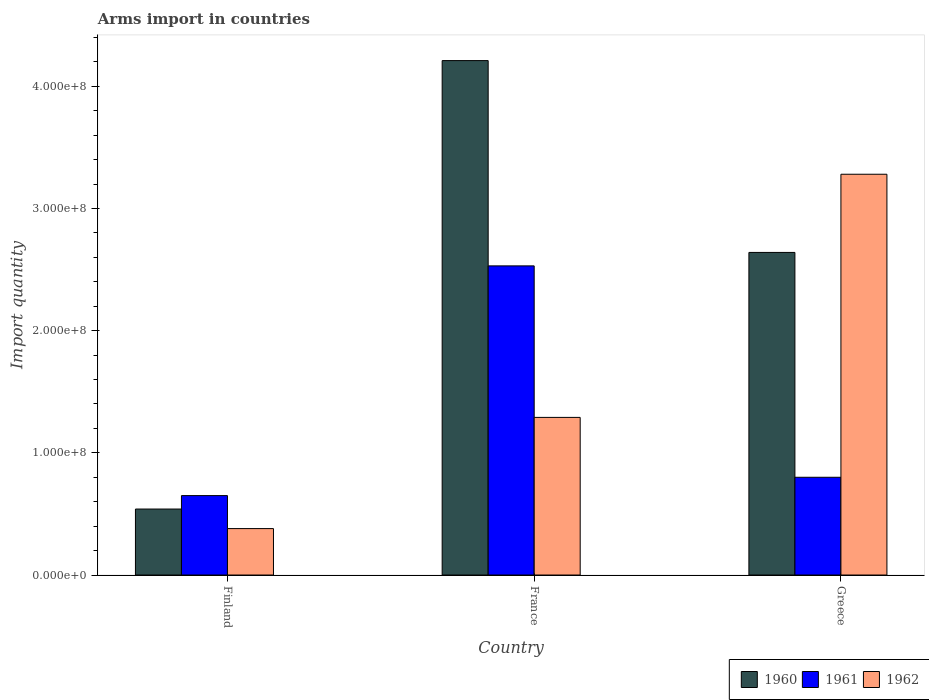How many different coloured bars are there?
Offer a terse response. 3. How many bars are there on the 1st tick from the right?
Provide a succinct answer. 3. What is the label of the 2nd group of bars from the left?
Offer a very short reply. France. What is the total arms import in 1960 in Greece?
Make the answer very short. 2.64e+08. Across all countries, what is the maximum total arms import in 1960?
Your response must be concise. 4.21e+08. Across all countries, what is the minimum total arms import in 1962?
Offer a terse response. 3.80e+07. What is the total total arms import in 1961 in the graph?
Give a very brief answer. 3.98e+08. What is the difference between the total arms import in 1962 in France and that in Greece?
Your answer should be compact. -1.99e+08. What is the difference between the total arms import in 1962 in Greece and the total arms import in 1961 in France?
Offer a very short reply. 7.50e+07. What is the average total arms import in 1961 per country?
Ensure brevity in your answer.  1.33e+08. What is the difference between the total arms import of/in 1960 and total arms import of/in 1962 in Finland?
Your answer should be compact. 1.60e+07. In how many countries, is the total arms import in 1962 greater than 400000000?
Give a very brief answer. 0. What is the ratio of the total arms import in 1960 in Finland to that in France?
Your answer should be very brief. 0.13. Is the difference between the total arms import in 1960 in France and Greece greater than the difference between the total arms import in 1962 in France and Greece?
Offer a very short reply. Yes. What is the difference between the highest and the second highest total arms import in 1960?
Give a very brief answer. 1.57e+08. What is the difference between the highest and the lowest total arms import in 1962?
Make the answer very short. 2.90e+08. In how many countries, is the total arms import in 1961 greater than the average total arms import in 1961 taken over all countries?
Offer a terse response. 1. Is the sum of the total arms import in 1962 in France and Greece greater than the maximum total arms import in 1960 across all countries?
Your answer should be compact. Yes. What does the 2nd bar from the left in France represents?
Your answer should be very brief. 1961. What does the 1st bar from the right in France represents?
Ensure brevity in your answer.  1962. Is it the case that in every country, the sum of the total arms import in 1960 and total arms import in 1962 is greater than the total arms import in 1961?
Offer a terse response. Yes. How many countries are there in the graph?
Offer a very short reply. 3. What is the difference between two consecutive major ticks on the Y-axis?
Offer a terse response. 1.00e+08. Are the values on the major ticks of Y-axis written in scientific E-notation?
Your answer should be very brief. Yes. Does the graph contain any zero values?
Provide a short and direct response. No. How many legend labels are there?
Your answer should be compact. 3. How are the legend labels stacked?
Your answer should be compact. Horizontal. What is the title of the graph?
Make the answer very short. Arms import in countries. What is the label or title of the X-axis?
Offer a very short reply. Country. What is the label or title of the Y-axis?
Offer a very short reply. Import quantity. What is the Import quantity in 1960 in Finland?
Your answer should be very brief. 5.40e+07. What is the Import quantity in 1961 in Finland?
Make the answer very short. 6.50e+07. What is the Import quantity of 1962 in Finland?
Give a very brief answer. 3.80e+07. What is the Import quantity of 1960 in France?
Give a very brief answer. 4.21e+08. What is the Import quantity in 1961 in France?
Provide a succinct answer. 2.53e+08. What is the Import quantity of 1962 in France?
Make the answer very short. 1.29e+08. What is the Import quantity of 1960 in Greece?
Your answer should be compact. 2.64e+08. What is the Import quantity in 1961 in Greece?
Keep it short and to the point. 8.00e+07. What is the Import quantity in 1962 in Greece?
Offer a terse response. 3.28e+08. Across all countries, what is the maximum Import quantity of 1960?
Offer a terse response. 4.21e+08. Across all countries, what is the maximum Import quantity in 1961?
Offer a terse response. 2.53e+08. Across all countries, what is the maximum Import quantity of 1962?
Your answer should be very brief. 3.28e+08. Across all countries, what is the minimum Import quantity of 1960?
Make the answer very short. 5.40e+07. Across all countries, what is the minimum Import quantity in 1961?
Your answer should be very brief. 6.50e+07. Across all countries, what is the minimum Import quantity of 1962?
Provide a succinct answer. 3.80e+07. What is the total Import quantity of 1960 in the graph?
Offer a very short reply. 7.39e+08. What is the total Import quantity of 1961 in the graph?
Offer a very short reply. 3.98e+08. What is the total Import quantity in 1962 in the graph?
Ensure brevity in your answer.  4.95e+08. What is the difference between the Import quantity in 1960 in Finland and that in France?
Offer a very short reply. -3.67e+08. What is the difference between the Import quantity of 1961 in Finland and that in France?
Your response must be concise. -1.88e+08. What is the difference between the Import quantity in 1962 in Finland and that in France?
Provide a short and direct response. -9.10e+07. What is the difference between the Import quantity in 1960 in Finland and that in Greece?
Provide a succinct answer. -2.10e+08. What is the difference between the Import quantity of 1961 in Finland and that in Greece?
Keep it short and to the point. -1.50e+07. What is the difference between the Import quantity in 1962 in Finland and that in Greece?
Your answer should be compact. -2.90e+08. What is the difference between the Import quantity of 1960 in France and that in Greece?
Make the answer very short. 1.57e+08. What is the difference between the Import quantity of 1961 in France and that in Greece?
Give a very brief answer. 1.73e+08. What is the difference between the Import quantity in 1962 in France and that in Greece?
Make the answer very short. -1.99e+08. What is the difference between the Import quantity in 1960 in Finland and the Import quantity in 1961 in France?
Ensure brevity in your answer.  -1.99e+08. What is the difference between the Import quantity in 1960 in Finland and the Import quantity in 1962 in France?
Provide a succinct answer. -7.50e+07. What is the difference between the Import quantity in 1961 in Finland and the Import quantity in 1962 in France?
Offer a terse response. -6.40e+07. What is the difference between the Import quantity in 1960 in Finland and the Import quantity in 1961 in Greece?
Your response must be concise. -2.60e+07. What is the difference between the Import quantity in 1960 in Finland and the Import quantity in 1962 in Greece?
Your response must be concise. -2.74e+08. What is the difference between the Import quantity of 1961 in Finland and the Import quantity of 1962 in Greece?
Provide a short and direct response. -2.63e+08. What is the difference between the Import quantity in 1960 in France and the Import quantity in 1961 in Greece?
Your response must be concise. 3.41e+08. What is the difference between the Import quantity of 1960 in France and the Import quantity of 1962 in Greece?
Provide a short and direct response. 9.30e+07. What is the difference between the Import quantity in 1961 in France and the Import quantity in 1962 in Greece?
Your answer should be compact. -7.50e+07. What is the average Import quantity of 1960 per country?
Offer a very short reply. 2.46e+08. What is the average Import quantity of 1961 per country?
Your answer should be compact. 1.33e+08. What is the average Import quantity of 1962 per country?
Make the answer very short. 1.65e+08. What is the difference between the Import quantity in 1960 and Import quantity in 1961 in Finland?
Offer a very short reply. -1.10e+07. What is the difference between the Import quantity of 1960 and Import quantity of 1962 in Finland?
Offer a terse response. 1.60e+07. What is the difference between the Import quantity of 1961 and Import quantity of 1962 in Finland?
Your response must be concise. 2.70e+07. What is the difference between the Import quantity in 1960 and Import quantity in 1961 in France?
Ensure brevity in your answer.  1.68e+08. What is the difference between the Import quantity of 1960 and Import quantity of 1962 in France?
Your answer should be compact. 2.92e+08. What is the difference between the Import quantity in 1961 and Import quantity in 1962 in France?
Offer a terse response. 1.24e+08. What is the difference between the Import quantity in 1960 and Import quantity in 1961 in Greece?
Your response must be concise. 1.84e+08. What is the difference between the Import quantity of 1960 and Import quantity of 1962 in Greece?
Offer a terse response. -6.40e+07. What is the difference between the Import quantity of 1961 and Import quantity of 1962 in Greece?
Make the answer very short. -2.48e+08. What is the ratio of the Import quantity in 1960 in Finland to that in France?
Provide a succinct answer. 0.13. What is the ratio of the Import quantity in 1961 in Finland to that in France?
Make the answer very short. 0.26. What is the ratio of the Import quantity of 1962 in Finland to that in France?
Make the answer very short. 0.29. What is the ratio of the Import quantity in 1960 in Finland to that in Greece?
Your answer should be very brief. 0.2. What is the ratio of the Import quantity in 1961 in Finland to that in Greece?
Make the answer very short. 0.81. What is the ratio of the Import quantity in 1962 in Finland to that in Greece?
Your answer should be very brief. 0.12. What is the ratio of the Import quantity of 1960 in France to that in Greece?
Your answer should be compact. 1.59. What is the ratio of the Import quantity in 1961 in France to that in Greece?
Your answer should be compact. 3.16. What is the ratio of the Import quantity in 1962 in France to that in Greece?
Provide a succinct answer. 0.39. What is the difference between the highest and the second highest Import quantity of 1960?
Keep it short and to the point. 1.57e+08. What is the difference between the highest and the second highest Import quantity in 1961?
Provide a short and direct response. 1.73e+08. What is the difference between the highest and the second highest Import quantity in 1962?
Give a very brief answer. 1.99e+08. What is the difference between the highest and the lowest Import quantity of 1960?
Offer a very short reply. 3.67e+08. What is the difference between the highest and the lowest Import quantity in 1961?
Your answer should be very brief. 1.88e+08. What is the difference between the highest and the lowest Import quantity in 1962?
Offer a very short reply. 2.90e+08. 